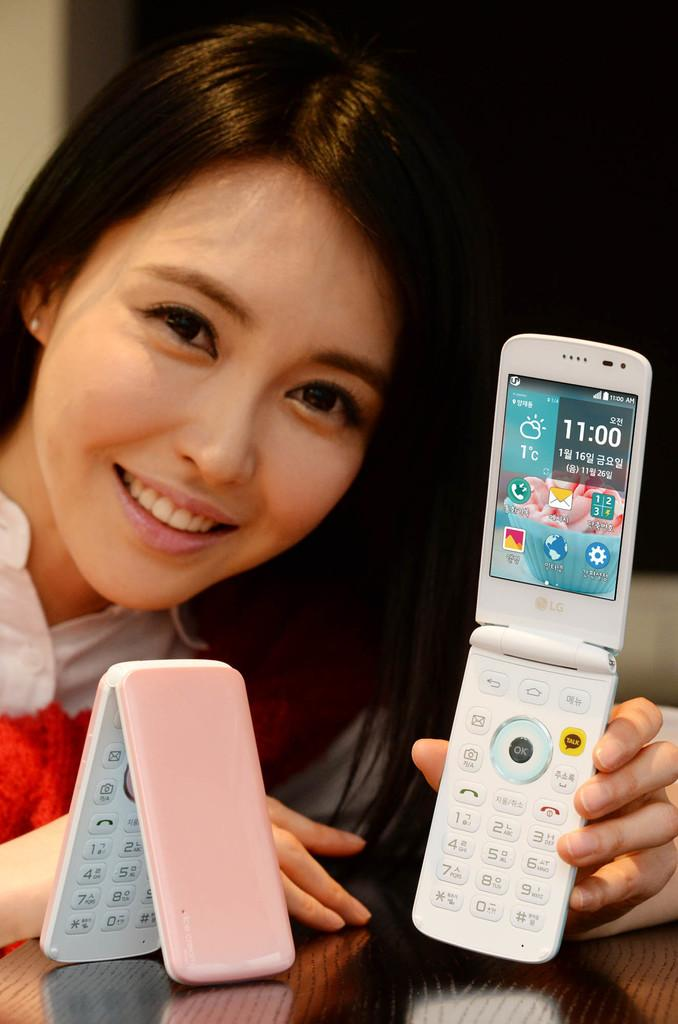<image>
Create a compact narrative representing the image presented. asian woman holding an lg flip phone and another pink and white flip phone next to her 